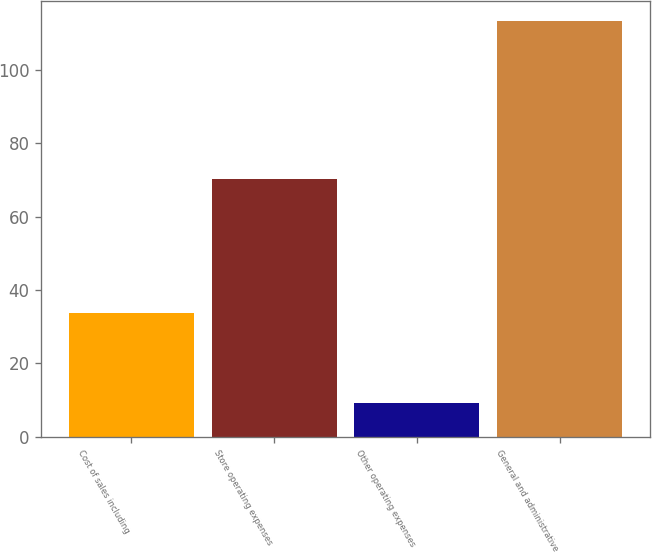Convert chart. <chart><loc_0><loc_0><loc_500><loc_500><bar_chart><fcel>Cost of sales including<fcel>Store operating expenses<fcel>Other operating expenses<fcel>General and administrative<nl><fcel>33.8<fcel>70.2<fcel>9.2<fcel>113.2<nl></chart> 